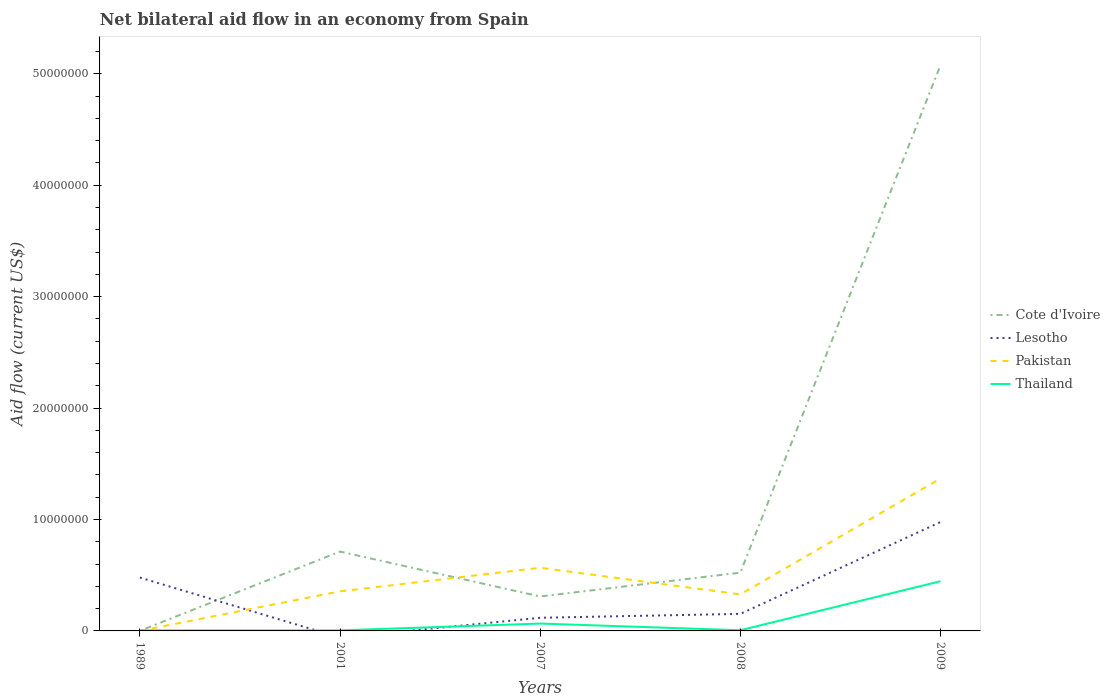What is the total net bilateral aid flow in Thailand in the graph?
Offer a very short reply. -3.80e+06. What is the difference between the highest and the second highest net bilateral aid flow in Cote d'Ivoire?
Offer a very short reply. 5.08e+07. What is the difference between the highest and the lowest net bilateral aid flow in Thailand?
Give a very brief answer. 1. How many lines are there?
Provide a short and direct response. 4. What is the difference between two consecutive major ticks on the Y-axis?
Your answer should be compact. 1.00e+07. Does the graph contain grids?
Offer a very short reply. No. How many legend labels are there?
Give a very brief answer. 4. What is the title of the graph?
Your answer should be very brief. Net bilateral aid flow in an economy from Spain. What is the label or title of the X-axis?
Provide a short and direct response. Years. What is the label or title of the Y-axis?
Make the answer very short. Aid flow (current US$). What is the Aid flow (current US$) in Cote d'Ivoire in 1989?
Offer a very short reply. 10000. What is the Aid flow (current US$) of Lesotho in 1989?
Your answer should be very brief. 4.79e+06. What is the Aid flow (current US$) in Cote d'Ivoire in 2001?
Give a very brief answer. 7.12e+06. What is the Aid flow (current US$) of Lesotho in 2001?
Give a very brief answer. 0. What is the Aid flow (current US$) in Pakistan in 2001?
Offer a very short reply. 3.55e+06. What is the Aid flow (current US$) in Thailand in 2001?
Make the answer very short. 5.00e+04. What is the Aid flow (current US$) of Cote d'Ivoire in 2007?
Give a very brief answer. 3.09e+06. What is the Aid flow (current US$) of Lesotho in 2007?
Your answer should be very brief. 1.18e+06. What is the Aid flow (current US$) in Pakistan in 2007?
Your answer should be compact. 5.67e+06. What is the Aid flow (current US$) in Cote d'Ivoire in 2008?
Your answer should be very brief. 5.23e+06. What is the Aid flow (current US$) of Lesotho in 2008?
Offer a very short reply. 1.53e+06. What is the Aid flow (current US$) in Pakistan in 2008?
Your response must be concise. 3.28e+06. What is the Aid flow (current US$) in Thailand in 2008?
Your answer should be compact. 6.00e+04. What is the Aid flow (current US$) of Cote d'Ivoire in 2009?
Your answer should be very brief. 5.08e+07. What is the Aid flow (current US$) in Lesotho in 2009?
Make the answer very short. 9.77e+06. What is the Aid flow (current US$) of Pakistan in 2009?
Keep it short and to the point. 1.37e+07. What is the Aid flow (current US$) of Thailand in 2009?
Your answer should be compact. 4.46e+06. Across all years, what is the maximum Aid flow (current US$) of Cote d'Ivoire?
Make the answer very short. 5.08e+07. Across all years, what is the maximum Aid flow (current US$) in Lesotho?
Keep it short and to the point. 9.77e+06. Across all years, what is the maximum Aid flow (current US$) of Pakistan?
Offer a terse response. 1.37e+07. Across all years, what is the maximum Aid flow (current US$) of Thailand?
Keep it short and to the point. 4.46e+06. Across all years, what is the minimum Aid flow (current US$) in Cote d'Ivoire?
Your response must be concise. 10000. Across all years, what is the minimum Aid flow (current US$) of Pakistan?
Your response must be concise. 10000. Across all years, what is the minimum Aid flow (current US$) of Thailand?
Offer a very short reply. 5.00e+04. What is the total Aid flow (current US$) in Cote d'Ivoire in the graph?
Ensure brevity in your answer.  6.62e+07. What is the total Aid flow (current US$) in Lesotho in the graph?
Your response must be concise. 1.73e+07. What is the total Aid flow (current US$) of Pakistan in the graph?
Keep it short and to the point. 2.62e+07. What is the total Aid flow (current US$) in Thailand in the graph?
Give a very brief answer. 5.28e+06. What is the difference between the Aid flow (current US$) of Cote d'Ivoire in 1989 and that in 2001?
Your answer should be compact. -7.11e+06. What is the difference between the Aid flow (current US$) in Pakistan in 1989 and that in 2001?
Make the answer very short. -3.54e+06. What is the difference between the Aid flow (current US$) of Thailand in 1989 and that in 2001?
Offer a very short reply. 0. What is the difference between the Aid flow (current US$) of Cote d'Ivoire in 1989 and that in 2007?
Offer a terse response. -3.08e+06. What is the difference between the Aid flow (current US$) in Lesotho in 1989 and that in 2007?
Provide a succinct answer. 3.61e+06. What is the difference between the Aid flow (current US$) of Pakistan in 1989 and that in 2007?
Give a very brief answer. -5.66e+06. What is the difference between the Aid flow (current US$) in Thailand in 1989 and that in 2007?
Your answer should be compact. -6.10e+05. What is the difference between the Aid flow (current US$) in Cote d'Ivoire in 1989 and that in 2008?
Give a very brief answer. -5.22e+06. What is the difference between the Aid flow (current US$) in Lesotho in 1989 and that in 2008?
Provide a succinct answer. 3.26e+06. What is the difference between the Aid flow (current US$) in Pakistan in 1989 and that in 2008?
Make the answer very short. -3.27e+06. What is the difference between the Aid flow (current US$) of Thailand in 1989 and that in 2008?
Provide a short and direct response. -10000. What is the difference between the Aid flow (current US$) of Cote d'Ivoire in 1989 and that in 2009?
Provide a succinct answer. -5.08e+07. What is the difference between the Aid flow (current US$) of Lesotho in 1989 and that in 2009?
Ensure brevity in your answer.  -4.98e+06. What is the difference between the Aid flow (current US$) of Pakistan in 1989 and that in 2009?
Provide a succinct answer. -1.37e+07. What is the difference between the Aid flow (current US$) of Thailand in 1989 and that in 2009?
Offer a terse response. -4.41e+06. What is the difference between the Aid flow (current US$) of Cote d'Ivoire in 2001 and that in 2007?
Your answer should be very brief. 4.03e+06. What is the difference between the Aid flow (current US$) in Pakistan in 2001 and that in 2007?
Keep it short and to the point. -2.12e+06. What is the difference between the Aid flow (current US$) in Thailand in 2001 and that in 2007?
Ensure brevity in your answer.  -6.10e+05. What is the difference between the Aid flow (current US$) in Cote d'Ivoire in 2001 and that in 2008?
Ensure brevity in your answer.  1.89e+06. What is the difference between the Aid flow (current US$) in Pakistan in 2001 and that in 2008?
Keep it short and to the point. 2.70e+05. What is the difference between the Aid flow (current US$) of Cote d'Ivoire in 2001 and that in 2009?
Provide a short and direct response. -4.36e+07. What is the difference between the Aid flow (current US$) of Pakistan in 2001 and that in 2009?
Your response must be concise. -1.01e+07. What is the difference between the Aid flow (current US$) of Thailand in 2001 and that in 2009?
Provide a short and direct response. -4.41e+06. What is the difference between the Aid flow (current US$) of Cote d'Ivoire in 2007 and that in 2008?
Ensure brevity in your answer.  -2.14e+06. What is the difference between the Aid flow (current US$) of Lesotho in 2007 and that in 2008?
Offer a very short reply. -3.50e+05. What is the difference between the Aid flow (current US$) of Pakistan in 2007 and that in 2008?
Offer a terse response. 2.39e+06. What is the difference between the Aid flow (current US$) of Thailand in 2007 and that in 2008?
Make the answer very short. 6.00e+05. What is the difference between the Aid flow (current US$) in Cote d'Ivoire in 2007 and that in 2009?
Your response must be concise. -4.77e+07. What is the difference between the Aid flow (current US$) in Lesotho in 2007 and that in 2009?
Give a very brief answer. -8.59e+06. What is the difference between the Aid flow (current US$) in Pakistan in 2007 and that in 2009?
Give a very brief answer. -8.01e+06. What is the difference between the Aid flow (current US$) in Thailand in 2007 and that in 2009?
Your answer should be very brief. -3.80e+06. What is the difference between the Aid flow (current US$) in Cote d'Ivoire in 2008 and that in 2009?
Provide a short and direct response. -4.55e+07. What is the difference between the Aid flow (current US$) in Lesotho in 2008 and that in 2009?
Keep it short and to the point. -8.24e+06. What is the difference between the Aid flow (current US$) of Pakistan in 2008 and that in 2009?
Keep it short and to the point. -1.04e+07. What is the difference between the Aid flow (current US$) in Thailand in 2008 and that in 2009?
Provide a succinct answer. -4.40e+06. What is the difference between the Aid flow (current US$) of Cote d'Ivoire in 1989 and the Aid flow (current US$) of Pakistan in 2001?
Your answer should be compact. -3.54e+06. What is the difference between the Aid flow (current US$) in Cote d'Ivoire in 1989 and the Aid flow (current US$) in Thailand in 2001?
Keep it short and to the point. -4.00e+04. What is the difference between the Aid flow (current US$) in Lesotho in 1989 and the Aid flow (current US$) in Pakistan in 2001?
Offer a terse response. 1.24e+06. What is the difference between the Aid flow (current US$) in Lesotho in 1989 and the Aid flow (current US$) in Thailand in 2001?
Your response must be concise. 4.74e+06. What is the difference between the Aid flow (current US$) of Cote d'Ivoire in 1989 and the Aid flow (current US$) of Lesotho in 2007?
Offer a terse response. -1.17e+06. What is the difference between the Aid flow (current US$) of Cote d'Ivoire in 1989 and the Aid flow (current US$) of Pakistan in 2007?
Make the answer very short. -5.66e+06. What is the difference between the Aid flow (current US$) in Cote d'Ivoire in 1989 and the Aid flow (current US$) in Thailand in 2007?
Provide a succinct answer. -6.50e+05. What is the difference between the Aid flow (current US$) of Lesotho in 1989 and the Aid flow (current US$) of Pakistan in 2007?
Offer a terse response. -8.80e+05. What is the difference between the Aid flow (current US$) of Lesotho in 1989 and the Aid flow (current US$) of Thailand in 2007?
Your response must be concise. 4.13e+06. What is the difference between the Aid flow (current US$) of Pakistan in 1989 and the Aid flow (current US$) of Thailand in 2007?
Provide a succinct answer. -6.50e+05. What is the difference between the Aid flow (current US$) in Cote d'Ivoire in 1989 and the Aid flow (current US$) in Lesotho in 2008?
Keep it short and to the point. -1.52e+06. What is the difference between the Aid flow (current US$) of Cote d'Ivoire in 1989 and the Aid flow (current US$) of Pakistan in 2008?
Provide a succinct answer. -3.27e+06. What is the difference between the Aid flow (current US$) of Lesotho in 1989 and the Aid flow (current US$) of Pakistan in 2008?
Provide a succinct answer. 1.51e+06. What is the difference between the Aid flow (current US$) in Lesotho in 1989 and the Aid flow (current US$) in Thailand in 2008?
Make the answer very short. 4.73e+06. What is the difference between the Aid flow (current US$) in Cote d'Ivoire in 1989 and the Aid flow (current US$) in Lesotho in 2009?
Offer a terse response. -9.76e+06. What is the difference between the Aid flow (current US$) of Cote d'Ivoire in 1989 and the Aid flow (current US$) of Pakistan in 2009?
Provide a succinct answer. -1.37e+07. What is the difference between the Aid flow (current US$) in Cote d'Ivoire in 1989 and the Aid flow (current US$) in Thailand in 2009?
Provide a succinct answer. -4.45e+06. What is the difference between the Aid flow (current US$) in Lesotho in 1989 and the Aid flow (current US$) in Pakistan in 2009?
Your answer should be compact. -8.89e+06. What is the difference between the Aid flow (current US$) of Pakistan in 1989 and the Aid flow (current US$) of Thailand in 2009?
Make the answer very short. -4.45e+06. What is the difference between the Aid flow (current US$) in Cote d'Ivoire in 2001 and the Aid flow (current US$) in Lesotho in 2007?
Keep it short and to the point. 5.94e+06. What is the difference between the Aid flow (current US$) in Cote d'Ivoire in 2001 and the Aid flow (current US$) in Pakistan in 2007?
Your answer should be compact. 1.45e+06. What is the difference between the Aid flow (current US$) of Cote d'Ivoire in 2001 and the Aid flow (current US$) of Thailand in 2007?
Offer a terse response. 6.46e+06. What is the difference between the Aid flow (current US$) in Pakistan in 2001 and the Aid flow (current US$) in Thailand in 2007?
Make the answer very short. 2.89e+06. What is the difference between the Aid flow (current US$) of Cote d'Ivoire in 2001 and the Aid flow (current US$) of Lesotho in 2008?
Your answer should be very brief. 5.59e+06. What is the difference between the Aid flow (current US$) of Cote d'Ivoire in 2001 and the Aid flow (current US$) of Pakistan in 2008?
Your answer should be very brief. 3.84e+06. What is the difference between the Aid flow (current US$) of Cote d'Ivoire in 2001 and the Aid flow (current US$) of Thailand in 2008?
Your answer should be compact. 7.06e+06. What is the difference between the Aid flow (current US$) of Pakistan in 2001 and the Aid flow (current US$) of Thailand in 2008?
Provide a short and direct response. 3.49e+06. What is the difference between the Aid flow (current US$) of Cote d'Ivoire in 2001 and the Aid flow (current US$) of Lesotho in 2009?
Your answer should be very brief. -2.65e+06. What is the difference between the Aid flow (current US$) of Cote d'Ivoire in 2001 and the Aid flow (current US$) of Pakistan in 2009?
Your answer should be very brief. -6.56e+06. What is the difference between the Aid flow (current US$) of Cote d'Ivoire in 2001 and the Aid flow (current US$) of Thailand in 2009?
Your response must be concise. 2.66e+06. What is the difference between the Aid flow (current US$) of Pakistan in 2001 and the Aid flow (current US$) of Thailand in 2009?
Provide a short and direct response. -9.10e+05. What is the difference between the Aid flow (current US$) in Cote d'Ivoire in 2007 and the Aid flow (current US$) in Lesotho in 2008?
Offer a very short reply. 1.56e+06. What is the difference between the Aid flow (current US$) in Cote d'Ivoire in 2007 and the Aid flow (current US$) in Pakistan in 2008?
Give a very brief answer. -1.90e+05. What is the difference between the Aid flow (current US$) of Cote d'Ivoire in 2007 and the Aid flow (current US$) of Thailand in 2008?
Ensure brevity in your answer.  3.03e+06. What is the difference between the Aid flow (current US$) in Lesotho in 2007 and the Aid flow (current US$) in Pakistan in 2008?
Ensure brevity in your answer.  -2.10e+06. What is the difference between the Aid flow (current US$) of Lesotho in 2007 and the Aid flow (current US$) of Thailand in 2008?
Ensure brevity in your answer.  1.12e+06. What is the difference between the Aid flow (current US$) in Pakistan in 2007 and the Aid flow (current US$) in Thailand in 2008?
Make the answer very short. 5.61e+06. What is the difference between the Aid flow (current US$) of Cote d'Ivoire in 2007 and the Aid flow (current US$) of Lesotho in 2009?
Ensure brevity in your answer.  -6.68e+06. What is the difference between the Aid flow (current US$) in Cote d'Ivoire in 2007 and the Aid flow (current US$) in Pakistan in 2009?
Offer a very short reply. -1.06e+07. What is the difference between the Aid flow (current US$) of Cote d'Ivoire in 2007 and the Aid flow (current US$) of Thailand in 2009?
Offer a terse response. -1.37e+06. What is the difference between the Aid flow (current US$) of Lesotho in 2007 and the Aid flow (current US$) of Pakistan in 2009?
Keep it short and to the point. -1.25e+07. What is the difference between the Aid flow (current US$) of Lesotho in 2007 and the Aid flow (current US$) of Thailand in 2009?
Provide a short and direct response. -3.28e+06. What is the difference between the Aid flow (current US$) in Pakistan in 2007 and the Aid flow (current US$) in Thailand in 2009?
Keep it short and to the point. 1.21e+06. What is the difference between the Aid flow (current US$) in Cote d'Ivoire in 2008 and the Aid flow (current US$) in Lesotho in 2009?
Keep it short and to the point. -4.54e+06. What is the difference between the Aid flow (current US$) of Cote d'Ivoire in 2008 and the Aid flow (current US$) of Pakistan in 2009?
Your answer should be very brief. -8.45e+06. What is the difference between the Aid flow (current US$) in Cote d'Ivoire in 2008 and the Aid flow (current US$) in Thailand in 2009?
Make the answer very short. 7.70e+05. What is the difference between the Aid flow (current US$) in Lesotho in 2008 and the Aid flow (current US$) in Pakistan in 2009?
Offer a terse response. -1.22e+07. What is the difference between the Aid flow (current US$) in Lesotho in 2008 and the Aid flow (current US$) in Thailand in 2009?
Offer a terse response. -2.93e+06. What is the difference between the Aid flow (current US$) of Pakistan in 2008 and the Aid flow (current US$) of Thailand in 2009?
Make the answer very short. -1.18e+06. What is the average Aid flow (current US$) in Cote d'Ivoire per year?
Ensure brevity in your answer.  1.32e+07. What is the average Aid flow (current US$) of Lesotho per year?
Provide a short and direct response. 3.45e+06. What is the average Aid flow (current US$) in Pakistan per year?
Make the answer very short. 5.24e+06. What is the average Aid flow (current US$) in Thailand per year?
Keep it short and to the point. 1.06e+06. In the year 1989, what is the difference between the Aid flow (current US$) in Cote d'Ivoire and Aid flow (current US$) in Lesotho?
Make the answer very short. -4.78e+06. In the year 1989, what is the difference between the Aid flow (current US$) of Cote d'Ivoire and Aid flow (current US$) of Pakistan?
Give a very brief answer. 0. In the year 1989, what is the difference between the Aid flow (current US$) of Cote d'Ivoire and Aid flow (current US$) of Thailand?
Provide a short and direct response. -4.00e+04. In the year 1989, what is the difference between the Aid flow (current US$) of Lesotho and Aid flow (current US$) of Pakistan?
Provide a short and direct response. 4.78e+06. In the year 1989, what is the difference between the Aid flow (current US$) in Lesotho and Aid flow (current US$) in Thailand?
Offer a very short reply. 4.74e+06. In the year 1989, what is the difference between the Aid flow (current US$) of Pakistan and Aid flow (current US$) of Thailand?
Your answer should be very brief. -4.00e+04. In the year 2001, what is the difference between the Aid flow (current US$) of Cote d'Ivoire and Aid flow (current US$) of Pakistan?
Give a very brief answer. 3.57e+06. In the year 2001, what is the difference between the Aid flow (current US$) in Cote d'Ivoire and Aid flow (current US$) in Thailand?
Keep it short and to the point. 7.07e+06. In the year 2001, what is the difference between the Aid flow (current US$) of Pakistan and Aid flow (current US$) of Thailand?
Give a very brief answer. 3.50e+06. In the year 2007, what is the difference between the Aid flow (current US$) of Cote d'Ivoire and Aid flow (current US$) of Lesotho?
Ensure brevity in your answer.  1.91e+06. In the year 2007, what is the difference between the Aid flow (current US$) in Cote d'Ivoire and Aid flow (current US$) in Pakistan?
Ensure brevity in your answer.  -2.58e+06. In the year 2007, what is the difference between the Aid flow (current US$) in Cote d'Ivoire and Aid flow (current US$) in Thailand?
Keep it short and to the point. 2.43e+06. In the year 2007, what is the difference between the Aid flow (current US$) in Lesotho and Aid flow (current US$) in Pakistan?
Your response must be concise. -4.49e+06. In the year 2007, what is the difference between the Aid flow (current US$) in Lesotho and Aid flow (current US$) in Thailand?
Provide a short and direct response. 5.20e+05. In the year 2007, what is the difference between the Aid flow (current US$) in Pakistan and Aid flow (current US$) in Thailand?
Make the answer very short. 5.01e+06. In the year 2008, what is the difference between the Aid flow (current US$) in Cote d'Ivoire and Aid flow (current US$) in Lesotho?
Provide a short and direct response. 3.70e+06. In the year 2008, what is the difference between the Aid flow (current US$) in Cote d'Ivoire and Aid flow (current US$) in Pakistan?
Your response must be concise. 1.95e+06. In the year 2008, what is the difference between the Aid flow (current US$) of Cote d'Ivoire and Aid flow (current US$) of Thailand?
Make the answer very short. 5.17e+06. In the year 2008, what is the difference between the Aid flow (current US$) of Lesotho and Aid flow (current US$) of Pakistan?
Give a very brief answer. -1.75e+06. In the year 2008, what is the difference between the Aid flow (current US$) in Lesotho and Aid flow (current US$) in Thailand?
Offer a very short reply. 1.47e+06. In the year 2008, what is the difference between the Aid flow (current US$) in Pakistan and Aid flow (current US$) in Thailand?
Give a very brief answer. 3.22e+06. In the year 2009, what is the difference between the Aid flow (current US$) of Cote d'Ivoire and Aid flow (current US$) of Lesotho?
Keep it short and to the point. 4.10e+07. In the year 2009, what is the difference between the Aid flow (current US$) in Cote d'Ivoire and Aid flow (current US$) in Pakistan?
Provide a succinct answer. 3.71e+07. In the year 2009, what is the difference between the Aid flow (current US$) in Cote d'Ivoire and Aid flow (current US$) in Thailand?
Keep it short and to the point. 4.63e+07. In the year 2009, what is the difference between the Aid flow (current US$) of Lesotho and Aid flow (current US$) of Pakistan?
Make the answer very short. -3.91e+06. In the year 2009, what is the difference between the Aid flow (current US$) in Lesotho and Aid flow (current US$) in Thailand?
Provide a succinct answer. 5.31e+06. In the year 2009, what is the difference between the Aid flow (current US$) in Pakistan and Aid flow (current US$) in Thailand?
Offer a terse response. 9.22e+06. What is the ratio of the Aid flow (current US$) of Cote d'Ivoire in 1989 to that in 2001?
Provide a short and direct response. 0. What is the ratio of the Aid flow (current US$) of Pakistan in 1989 to that in 2001?
Your answer should be very brief. 0. What is the ratio of the Aid flow (current US$) of Thailand in 1989 to that in 2001?
Offer a very short reply. 1. What is the ratio of the Aid flow (current US$) of Cote d'Ivoire in 1989 to that in 2007?
Your answer should be compact. 0. What is the ratio of the Aid flow (current US$) of Lesotho in 1989 to that in 2007?
Your answer should be compact. 4.06. What is the ratio of the Aid flow (current US$) of Pakistan in 1989 to that in 2007?
Provide a succinct answer. 0. What is the ratio of the Aid flow (current US$) in Thailand in 1989 to that in 2007?
Make the answer very short. 0.08. What is the ratio of the Aid flow (current US$) in Cote d'Ivoire in 1989 to that in 2008?
Make the answer very short. 0. What is the ratio of the Aid flow (current US$) of Lesotho in 1989 to that in 2008?
Offer a very short reply. 3.13. What is the ratio of the Aid flow (current US$) in Pakistan in 1989 to that in 2008?
Give a very brief answer. 0. What is the ratio of the Aid flow (current US$) in Thailand in 1989 to that in 2008?
Your answer should be very brief. 0.83. What is the ratio of the Aid flow (current US$) of Cote d'Ivoire in 1989 to that in 2009?
Make the answer very short. 0. What is the ratio of the Aid flow (current US$) in Lesotho in 1989 to that in 2009?
Your answer should be very brief. 0.49. What is the ratio of the Aid flow (current US$) of Pakistan in 1989 to that in 2009?
Your response must be concise. 0. What is the ratio of the Aid flow (current US$) of Thailand in 1989 to that in 2009?
Make the answer very short. 0.01. What is the ratio of the Aid flow (current US$) in Cote d'Ivoire in 2001 to that in 2007?
Your answer should be very brief. 2.3. What is the ratio of the Aid flow (current US$) of Pakistan in 2001 to that in 2007?
Keep it short and to the point. 0.63. What is the ratio of the Aid flow (current US$) of Thailand in 2001 to that in 2007?
Give a very brief answer. 0.08. What is the ratio of the Aid flow (current US$) of Cote d'Ivoire in 2001 to that in 2008?
Provide a short and direct response. 1.36. What is the ratio of the Aid flow (current US$) in Pakistan in 2001 to that in 2008?
Your response must be concise. 1.08. What is the ratio of the Aid flow (current US$) of Cote d'Ivoire in 2001 to that in 2009?
Offer a terse response. 0.14. What is the ratio of the Aid flow (current US$) of Pakistan in 2001 to that in 2009?
Provide a short and direct response. 0.26. What is the ratio of the Aid flow (current US$) in Thailand in 2001 to that in 2009?
Offer a very short reply. 0.01. What is the ratio of the Aid flow (current US$) of Cote d'Ivoire in 2007 to that in 2008?
Your response must be concise. 0.59. What is the ratio of the Aid flow (current US$) in Lesotho in 2007 to that in 2008?
Your response must be concise. 0.77. What is the ratio of the Aid flow (current US$) in Pakistan in 2007 to that in 2008?
Keep it short and to the point. 1.73. What is the ratio of the Aid flow (current US$) in Thailand in 2007 to that in 2008?
Ensure brevity in your answer.  11. What is the ratio of the Aid flow (current US$) of Cote d'Ivoire in 2007 to that in 2009?
Provide a succinct answer. 0.06. What is the ratio of the Aid flow (current US$) of Lesotho in 2007 to that in 2009?
Make the answer very short. 0.12. What is the ratio of the Aid flow (current US$) in Pakistan in 2007 to that in 2009?
Ensure brevity in your answer.  0.41. What is the ratio of the Aid flow (current US$) of Thailand in 2007 to that in 2009?
Keep it short and to the point. 0.15. What is the ratio of the Aid flow (current US$) in Cote d'Ivoire in 2008 to that in 2009?
Provide a short and direct response. 0.1. What is the ratio of the Aid flow (current US$) of Lesotho in 2008 to that in 2009?
Provide a succinct answer. 0.16. What is the ratio of the Aid flow (current US$) in Pakistan in 2008 to that in 2009?
Offer a terse response. 0.24. What is the ratio of the Aid flow (current US$) in Thailand in 2008 to that in 2009?
Your response must be concise. 0.01. What is the difference between the highest and the second highest Aid flow (current US$) of Cote d'Ivoire?
Provide a short and direct response. 4.36e+07. What is the difference between the highest and the second highest Aid flow (current US$) in Lesotho?
Your answer should be compact. 4.98e+06. What is the difference between the highest and the second highest Aid flow (current US$) of Pakistan?
Your response must be concise. 8.01e+06. What is the difference between the highest and the second highest Aid flow (current US$) of Thailand?
Your answer should be very brief. 3.80e+06. What is the difference between the highest and the lowest Aid flow (current US$) in Cote d'Ivoire?
Your response must be concise. 5.08e+07. What is the difference between the highest and the lowest Aid flow (current US$) in Lesotho?
Your answer should be compact. 9.77e+06. What is the difference between the highest and the lowest Aid flow (current US$) in Pakistan?
Provide a short and direct response. 1.37e+07. What is the difference between the highest and the lowest Aid flow (current US$) in Thailand?
Ensure brevity in your answer.  4.41e+06. 